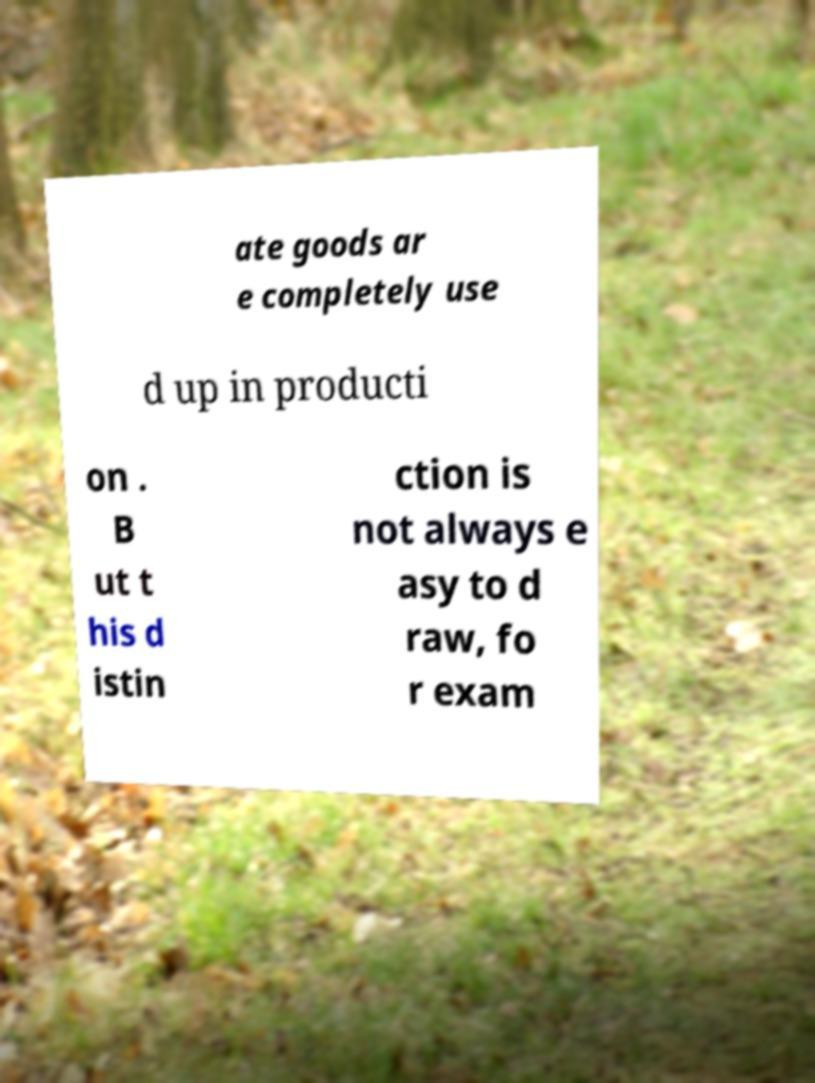Could you assist in decoding the text presented in this image and type it out clearly? ate goods ar e completely use d up in producti on . B ut t his d istin ction is not always e asy to d raw, fo r exam 